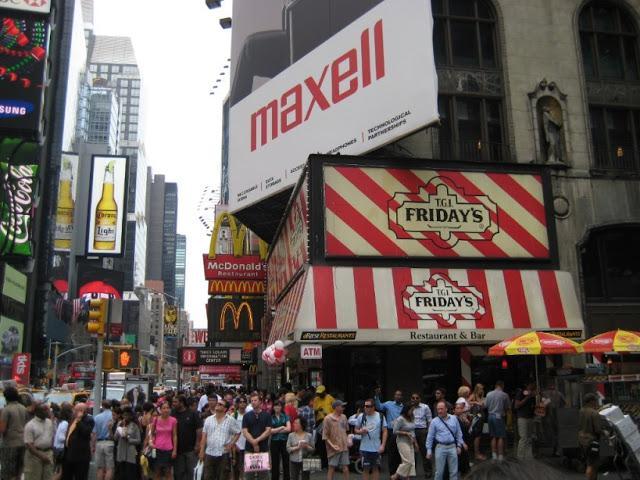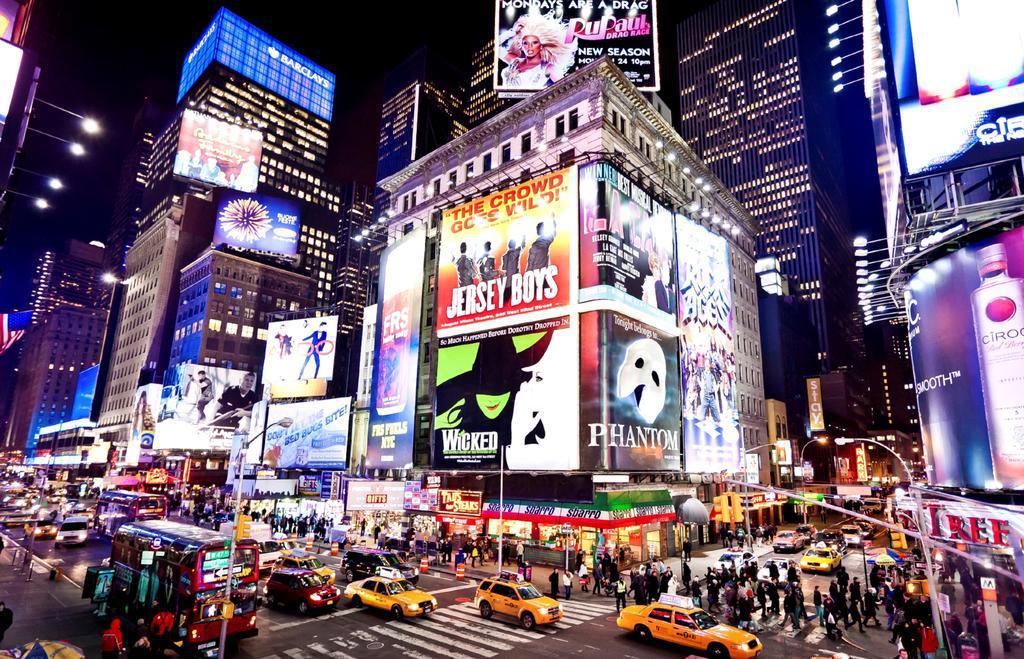The first image is the image on the left, the second image is the image on the right. For the images displayed, is the sentence "It is night in the right image, with lots of lit up buildings." factually correct? Answer yes or no. Yes. The first image is the image on the left, the second image is the image on the right. Examine the images to the left and right. Is the description "There are at least four yellow taxi cabs." accurate? Answer yes or no. Yes. 